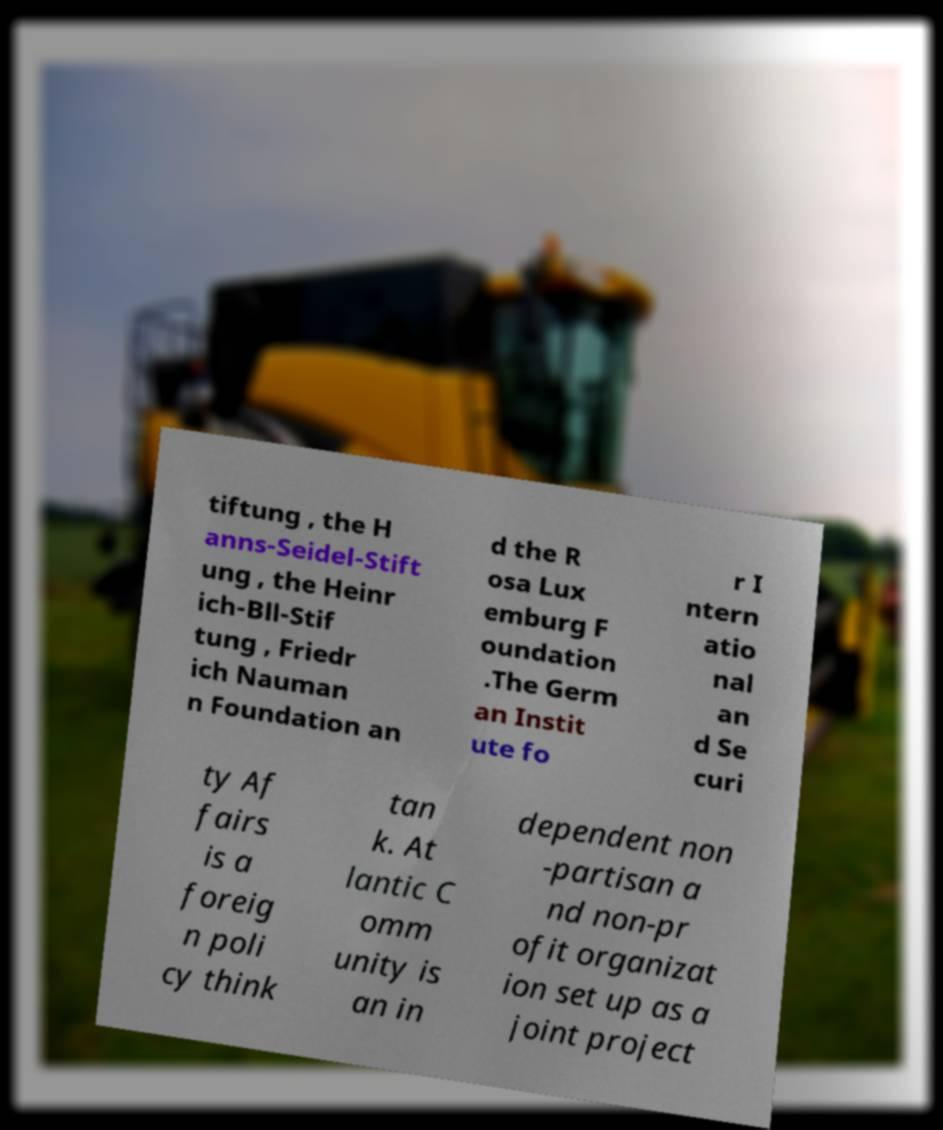For documentation purposes, I need the text within this image transcribed. Could you provide that? tiftung , the H anns-Seidel-Stift ung , the Heinr ich-Bll-Stif tung , Friedr ich Nauman n Foundation an d the R osa Lux emburg F oundation .The Germ an Instit ute fo r I ntern atio nal an d Se curi ty Af fairs is a foreig n poli cy think tan k. At lantic C omm unity is an in dependent non -partisan a nd non-pr ofit organizat ion set up as a joint project 